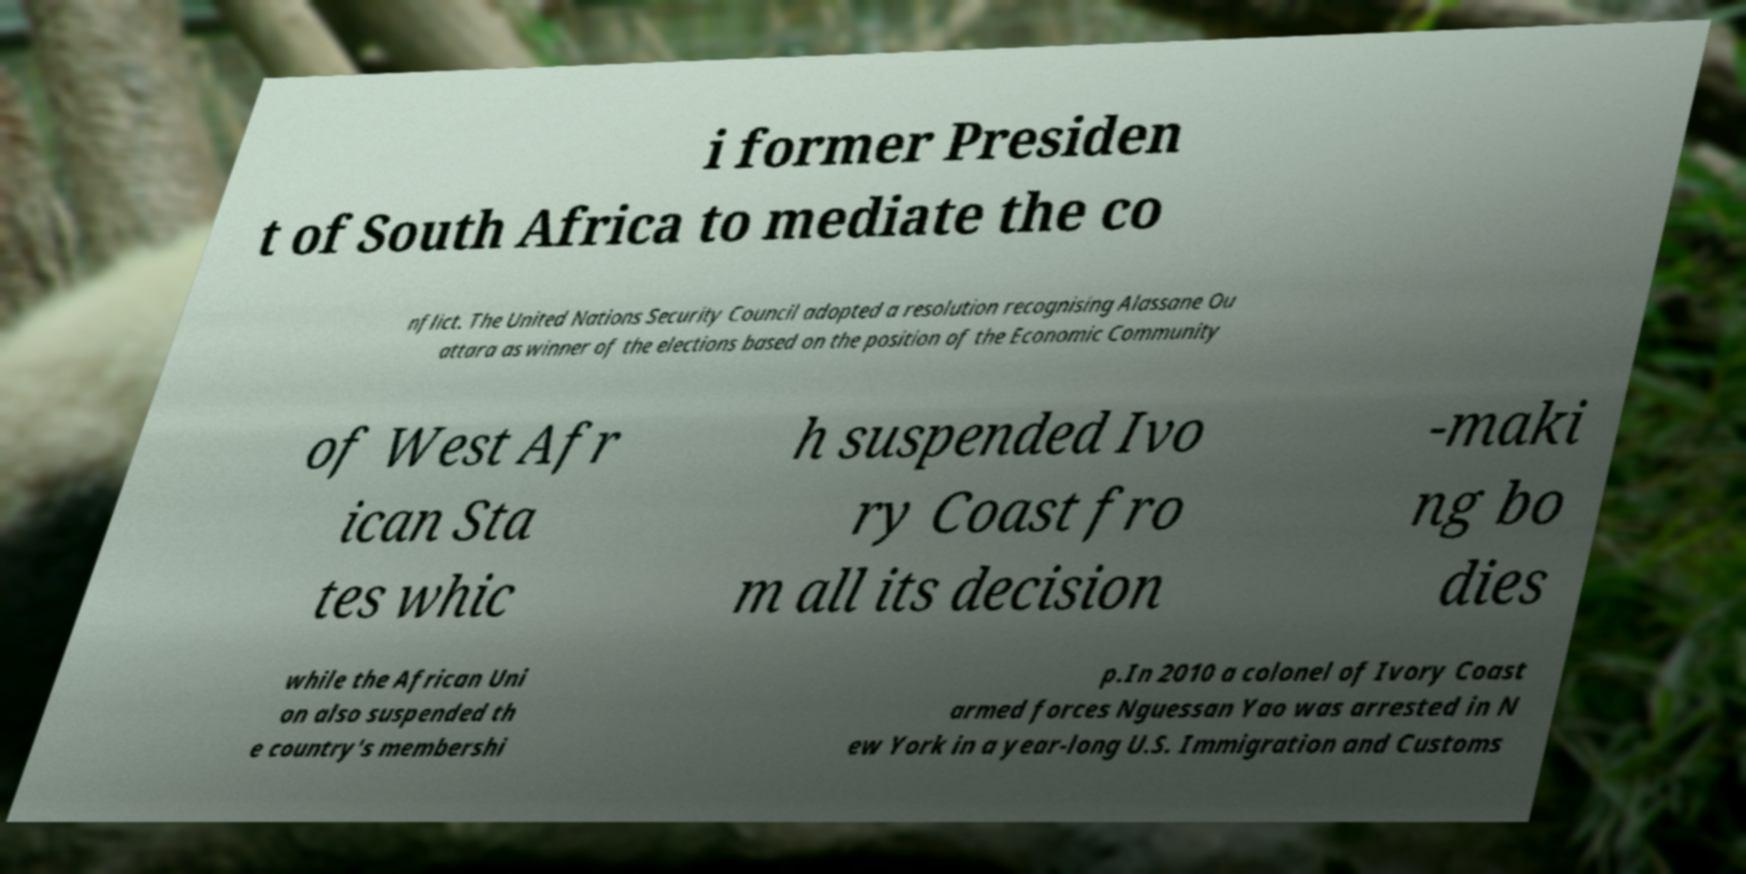What messages or text are displayed in this image? I need them in a readable, typed format. i former Presiden t of South Africa to mediate the co nflict. The United Nations Security Council adopted a resolution recognising Alassane Ou attara as winner of the elections based on the position of the Economic Community of West Afr ican Sta tes whic h suspended Ivo ry Coast fro m all its decision -maki ng bo dies while the African Uni on also suspended th e country's membershi p.In 2010 a colonel of Ivory Coast armed forces Nguessan Yao was arrested in N ew York in a year-long U.S. Immigration and Customs 